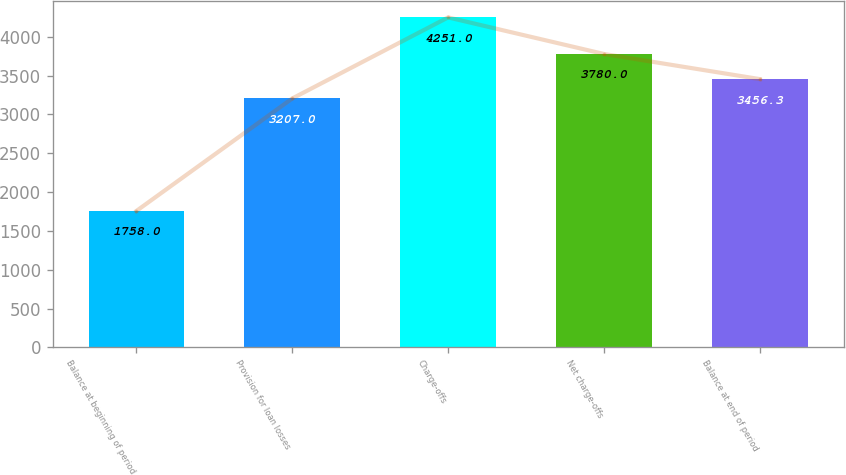Convert chart to OTSL. <chart><loc_0><loc_0><loc_500><loc_500><bar_chart><fcel>Balance at beginning of period<fcel>Provision for loan losses<fcel>Charge-offs<fcel>Net charge-offs<fcel>Balance at end of period<nl><fcel>1758<fcel>3207<fcel>4251<fcel>3780<fcel>3456.3<nl></chart> 